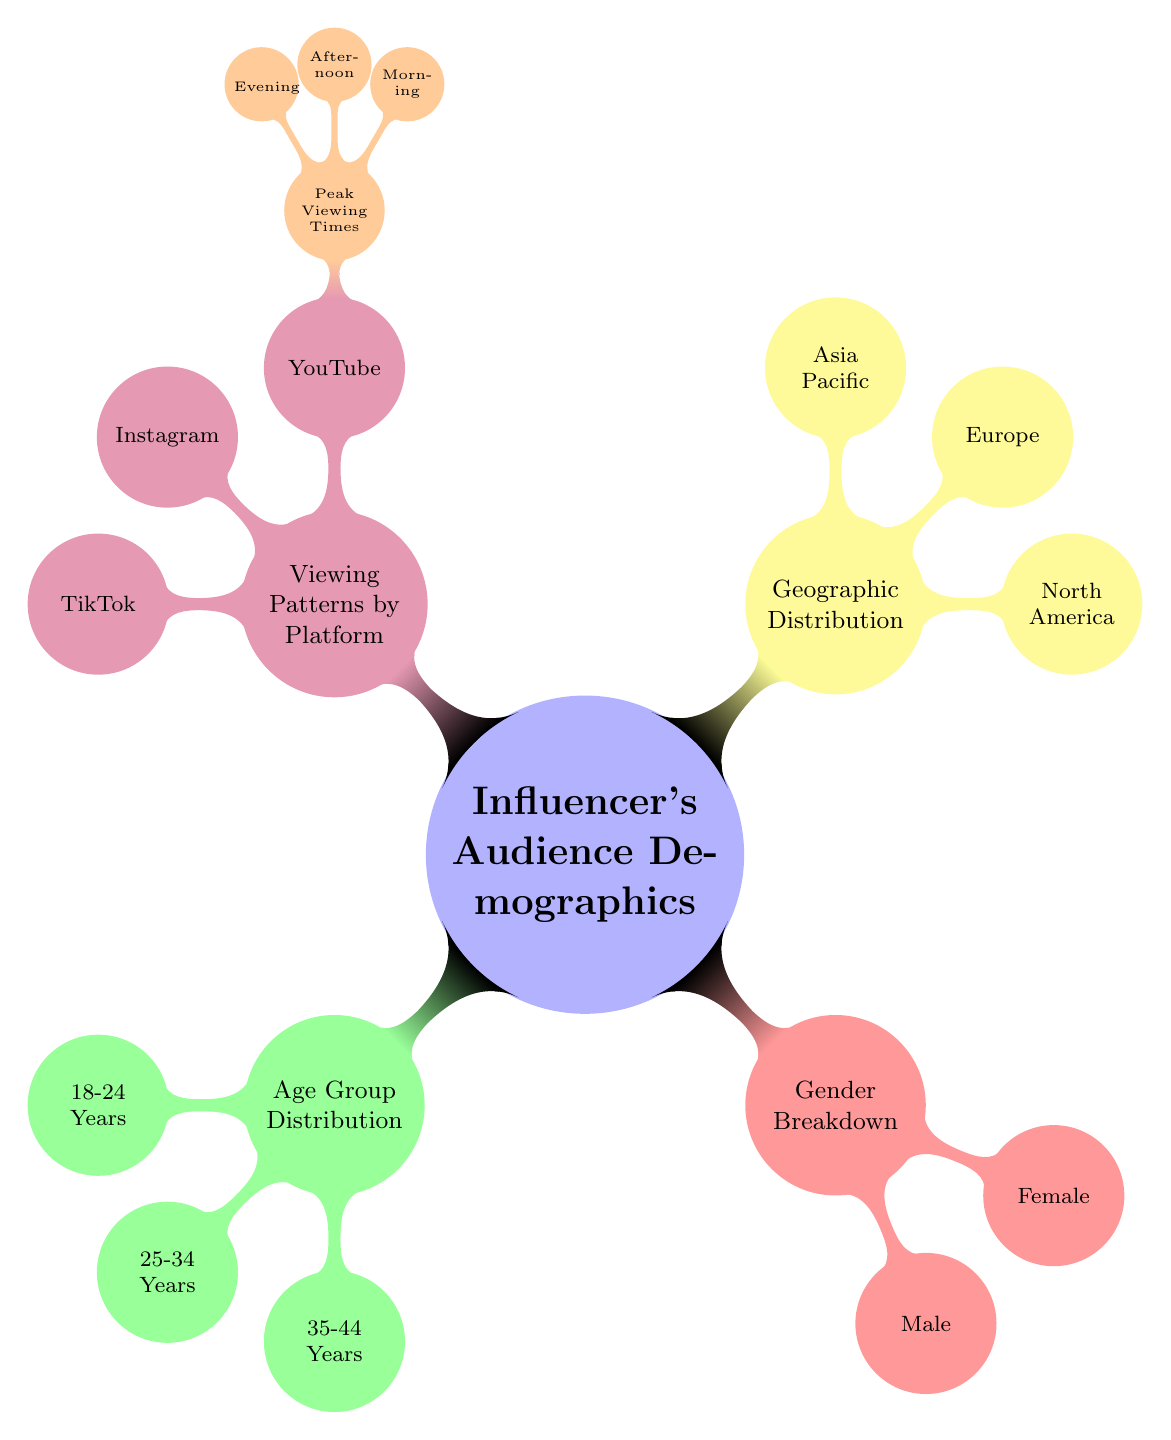What is the top age group represented in the influencer's audience? The diagram shows three age groups: 18-24 years, 25-34 years, and 35-44 years. Since none of these groups indicate ranking or size, we take the first group listed, which is 18-24 years.
Answer: 18-24 Years How many main demographic categories are shown in the diagram? The diagram displays four main categories: Age Group Distribution, Gender Breakdown, Geographic Distribution, and Viewing Patterns by Platform. Counting these categories gives us a total of four.
Answer: 4 Which platform shows peak viewing times in the diagram? The diagram highlights YouTube under the Viewing Patterns by Platform section, specifically mentioning Peak Viewing Times as a subcategory. This indicates that YouTube is the platform with peak viewing times shown.
Answer: YouTube What is the total number of gender breakdown categories in the diagram? The Gender Breakdown section has two categories: Male and Female. Adding these gives a total of two categories for gender.
Answer: 2 Which age group is not represented in the influencer's audience demographics? The diagram lists only three specific age groups: 18-24 years, 25-34 years, and 35-44 years. It does not include age groups such as under 18 or over 44 years, which are therefore not represented.
Answer: Under 18 and Over 44 Years What is the geographic region that is included in the demographic distribution? The Geographic Distribution node lists three regions: North America, Europe, and Asia Pacific. Any demographic data for regions outside of these three would not be included.
Answer: North America, Europe, Asia Pacific In terms of viewing patterns, which time of day has been specified for YouTube? Within the YouTube section of Viewing Patterns by Platform, three times are mentioned as Peak Viewing Times: Morning, Afternoon, and Evening. Hence, all these times can be considered specified time slots.
Answer: Morning, Afternoon, Evening How does the number of geographic regions compare to age groups in the diagram? The Geographic Distribution node features three regions, while the Age Group Distribution category shows three age groups. Therefore, both categories have the same number.
Answer: Same number (3 each) 